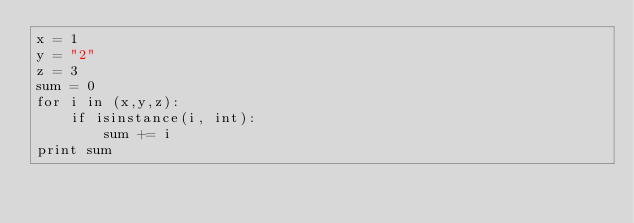Convert code to text. <code><loc_0><loc_0><loc_500><loc_500><_Python_>x = 1
y = "2"
z = 3
sum = 0
for i in (x,y,z):
    if isinstance(i, int):
        sum += i
print sum 
</code> 